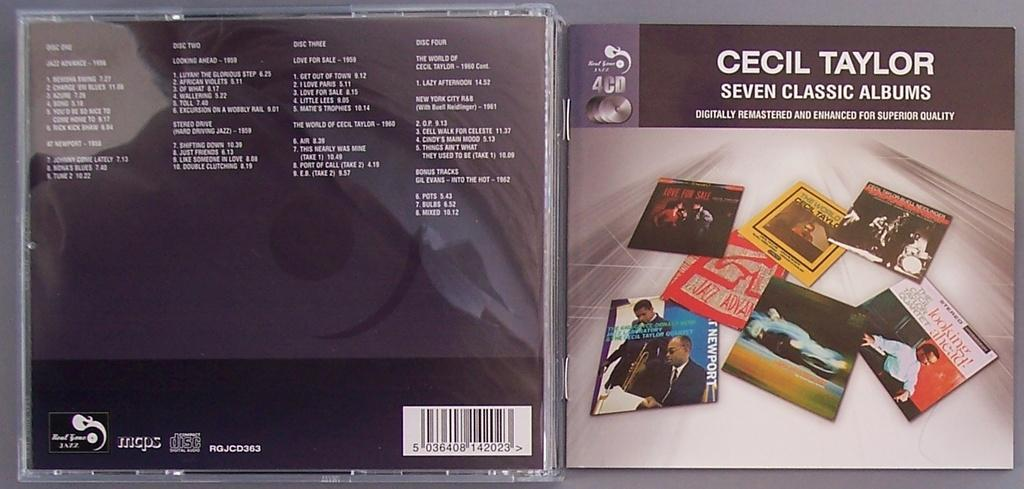<image>
Create a compact narrative representing the image presented. The cover of the Cecil Taylor album features covers of seven albums. 